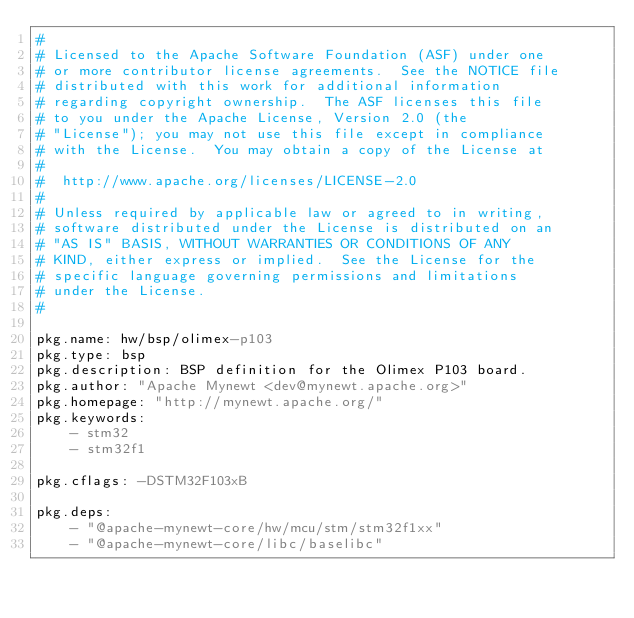<code> <loc_0><loc_0><loc_500><loc_500><_YAML_>#
# Licensed to the Apache Software Foundation (ASF) under one
# or more contributor license agreements.  See the NOTICE file
# distributed with this work for additional information
# regarding copyright ownership.  The ASF licenses this file
# to you under the Apache License, Version 2.0 (the
# "License"); you may not use this file except in compliance
# with the License.  You may obtain a copy of the License at
# 
#  http://www.apache.org/licenses/LICENSE-2.0
#
# Unless required by applicable law or agreed to in writing,
# software distributed under the License is distributed on an
# "AS IS" BASIS, WITHOUT WARRANTIES OR CONDITIONS OF ANY
# KIND, either express or implied.  See the License for the
# specific language governing permissions and limitations
# under the License.
#

pkg.name: hw/bsp/olimex-p103
pkg.type: bsp
pkg.description: BSP definition for the Olimex P103 board.
pkg.author: "Apache Mynewt <dev@mynewt.apache.org>"
pkg.homepage: "http://mynewt.apache.org/"
pkg.keywords:
    - stm32
    - stm32f1

pkg.cflags: -DSTM32F103xB

pkg.deps:
    - "@apache-mynewt-core/hw/mcu/stm/stm32f1xx"
    - "@apache-mynewt-core/libc/baselibc"
</code> 